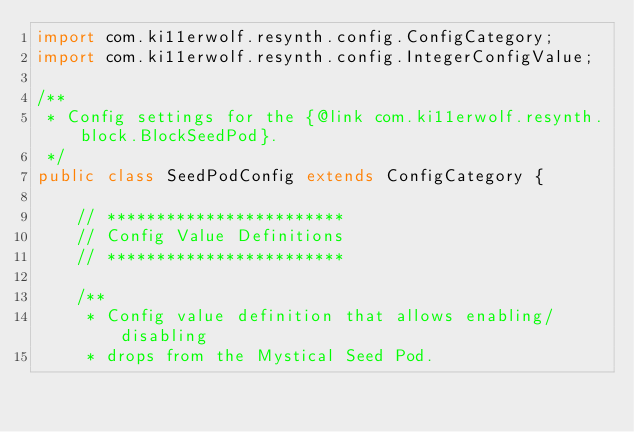Convert code to text. <code><loc_0><loc_0><loc_500><loc_500><_Java_>import com.ki11erwolf.resynth.config.ConfigCategory;
import com.ki11erwolf.resynth.config.IntegerConfigValue;

/**
 * Config settings for the {@link com.ki11erwolf.resynth.block.BlockSeedPod}.
 */
public class SeedPodConfig extends ConfigCategory {

    // ************************
    // Config Value Definitions
    // ************************

    /**
     * Config value definition that allows enabling/disabling
     * drops from the Mystical Seed Pod.</code> 